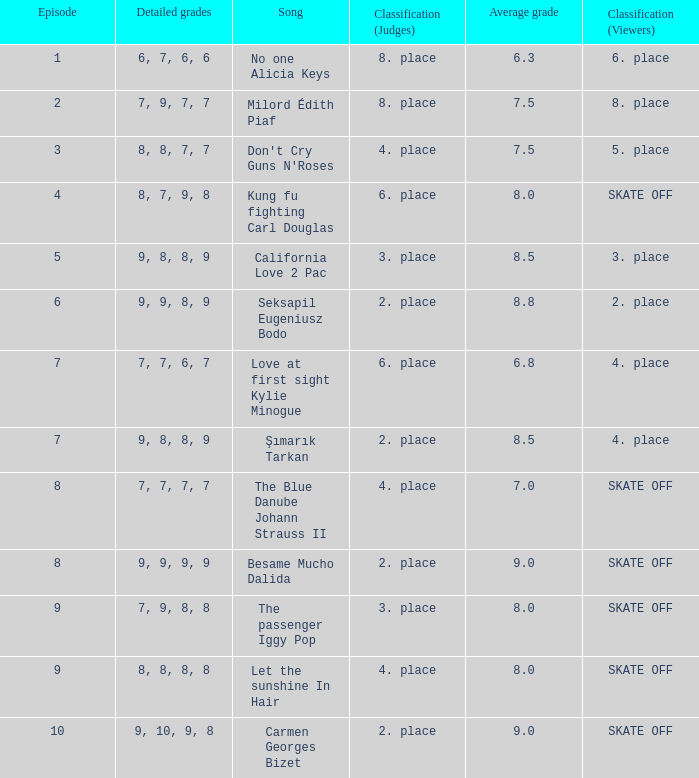Name the classification for 9, 9, 8, 9 2. place. 